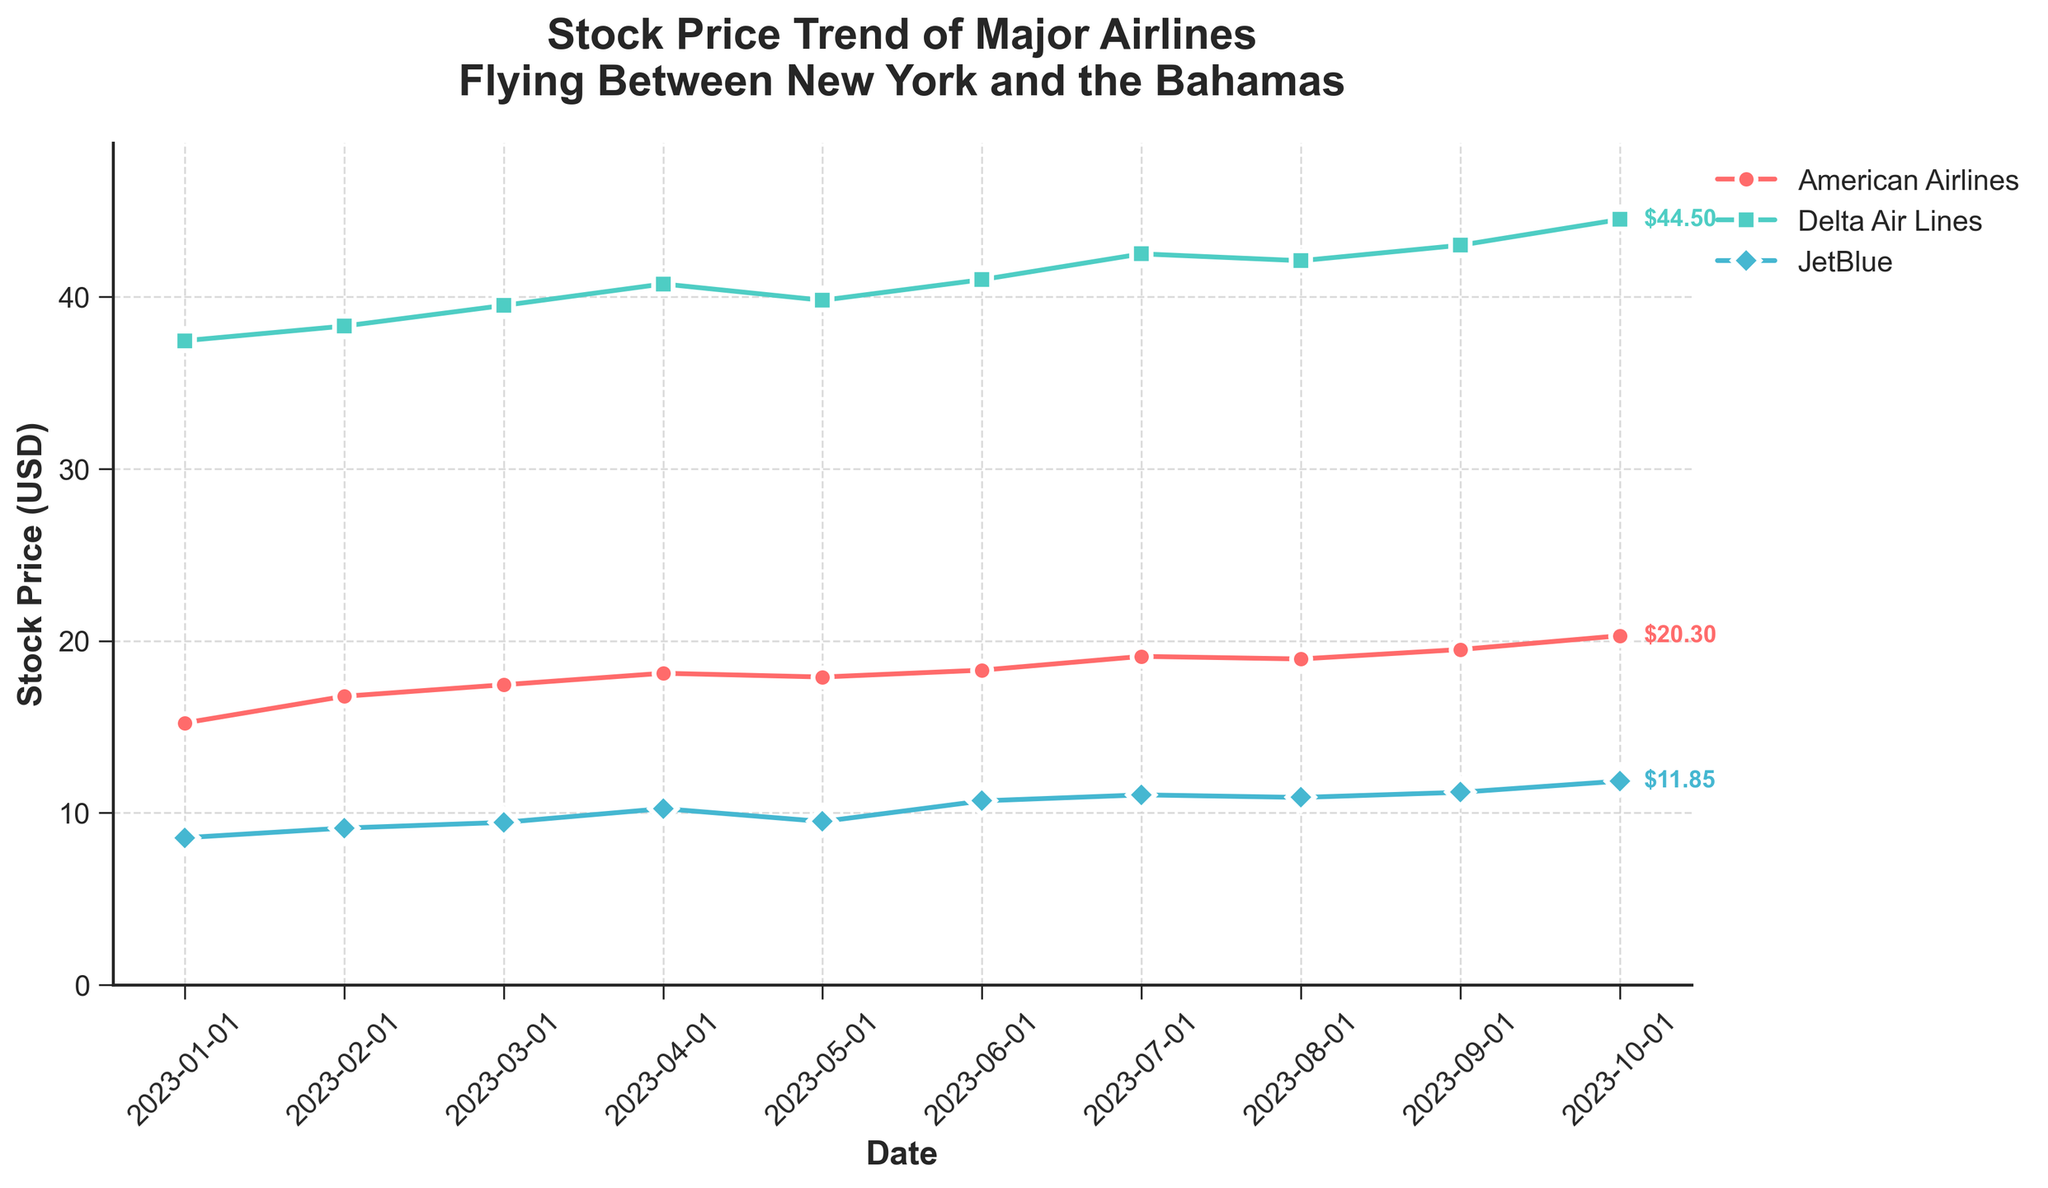What's the title of the plot? The title is usually located at the top of the plot. In this case, it is "Stock Price Trend of Major Airlines Flying Between New York and the Bahamas."
Answer: Stock Price Trend of Major Airlines Flying Between New York and the Bahamas Which airline had the lowest stock price on January 1, 2023? On January 1, 2023, the stock prices were 15.23 USD for American Airlines, 37.45 USD for Delta Air Lines, and 8.56 USD for JetBlue. The lowest of these is 8.56 USD.
Answer: JetBlue What is the overall trend of American Airlines' stock price from January to October 2023? By examining the plot for American Airlines, the stock price increases from January (15.23 USD) to October (20.30 USD). Overall, the trend is upward.
Answer: Upward trend What was the stock price of Delta Air Lines in July 2023? Looking at the data points for Delta Air Lines in July 2023, the stock price is marked as 42.50 USD.
Answer: 42.50 USD From the data available, which month showed the highest stock price for all airlines? By comparing the stock prices of all airlines across the months, October 2023 shows the highest value for each airline: 20.30 USD for American Airlines, 44.50 USD for Delta Air Lines, and 11.85 USD for JetBlue.
Answer: October 2023 How much did JetBlue’s stock price increase from January 2023 to October 2023? JetBlue's stock price was 8.56 USD in January 2023 and increased to 11.85 USD by October 2023. The increase is calculated as 11.85 - 8.56.
Answer: 3.29 USD Which airline had the greatest overall increase in stock price from January to October 2023? The increase is calculated by subtracting the January stock prices from the October prices for each airline. The respective increases are:
- American Airlines: 20.30 - 15.23 = 5.07 USD
- Delta Air Lines: 44.50 - 37.45 = 7.05 USD
- JetBlue: 11.85 - 8.56 = 3.29 USD
Delta Air Lines has the greatest overall increase.
Answer: Delta Air Lines Compare the stock price trends of Delta Air Lines and JetBlue. Which airline had a more consistent upward trend? By observing the plot, Delta Air Lines shows a relatively consistent upward trajectory, while JetBlue's stock price fluctuates more with occasional drops. Delta Air Lines had a more consistent upward trend.
Answer: Delta Air Lines How did American Airlines' stock price change from May to June 2023? The stock price for American Airlines in May was 17.90 USD, and in June, it was 18.30 USD. The difference is 18.30 - 17.90.
Answer: Increased by 0.40 USD 